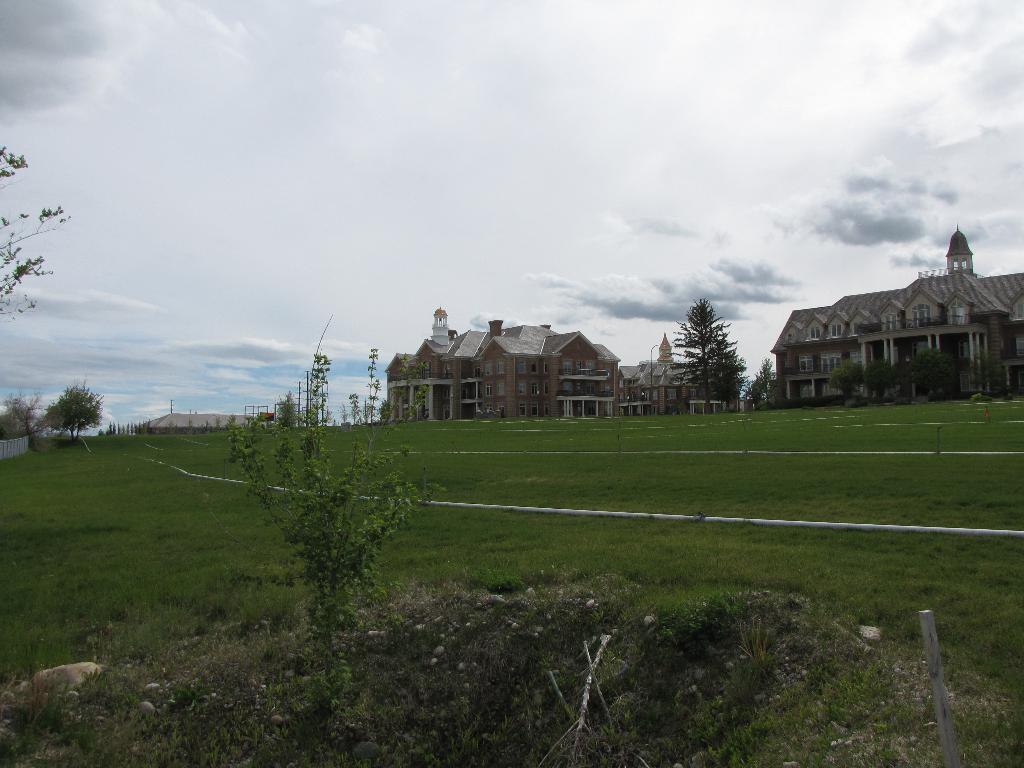In one or two sentences, can you explain what this image depicts? In this picture I can observe some grass and plants on the ground. In the background there are buildings and I can observe sky. 